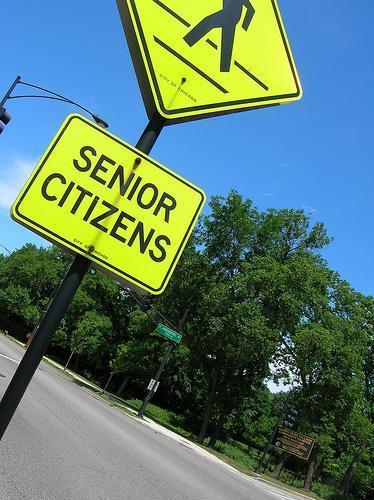How many stoplights are visible?
Give a very brief answer. 2. 